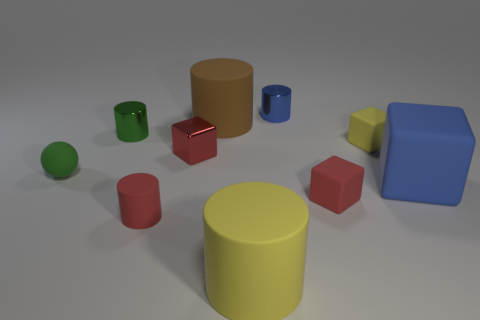How many tiny things are red metal objects or gray objects?
Make the answer very short. 1. There is a yellow object that is the same shape as the blue rubber object; what is its material?
Provide a short and direct response. Rubber. Are there any other things that are the same material as the large brown cylinder?
Make the answer very short. Yes. The ball is what color?
Keep it short and to the point. Green. Is the metal block the same color as the large matte block?
Provide a succinct answer. No. How many red cubes are on the right side of the tiny cube in front of the ball?
Your answer should be very brief. 0. There is a thing that is in front of the tiny ball and on the right side of the red rubber cube; what is its size?
Make the answer very short. Large. There is a small red object behind the green matte object; what is it made of?
Your response must be concise. Metal. Are there any green objects that have the same shape as the small red metal object?
Offer a terse response. No. How many blue rubber objects are the same shape as the brown matte object?
Make the answer very short. 0. 